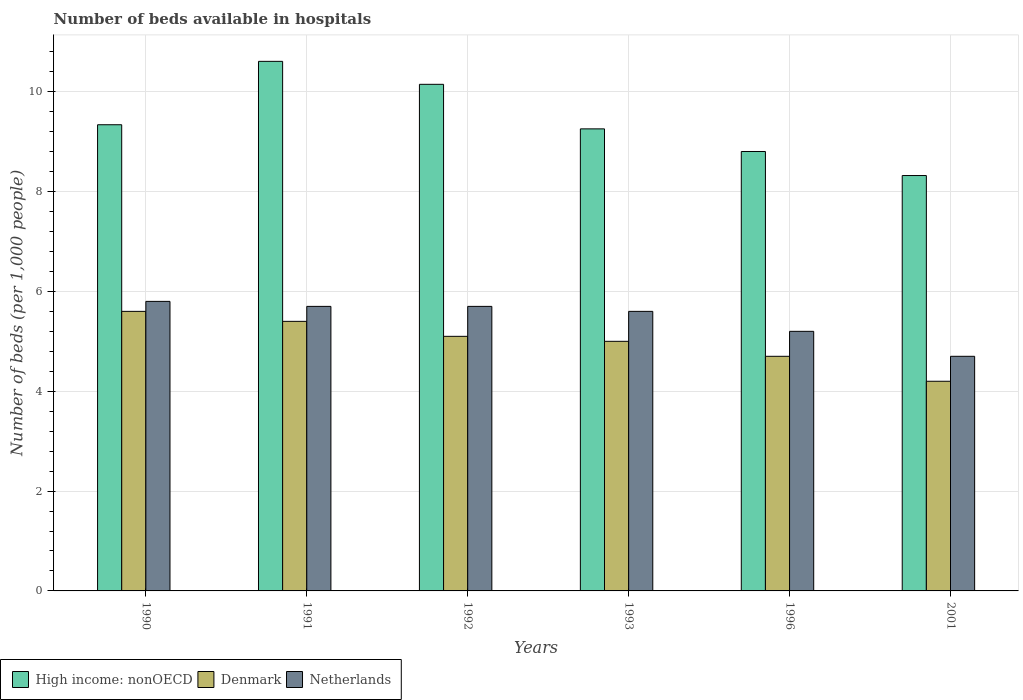How many bars are there on the 6th tick from the right?
Give a very brief answer. 3. What is the label of the 3rd group of bars from the left?
Provide a short and direct response. 1992. In how many cases, is the number of bars for a given year not equal to the number of legend labels?
Give a very brief answer. 0. What is the number of beds in the hospiatls of in High income: nonOECD in 1991?
Ensure brevity in your answer.  10.61. Across all years, what is the maximum number of beds in the hospiatls of in Netherlands?
Offer a terse response. 5.8. Across all years, what is the minimum number of beds in the hospiatls of in High income: nonOECD?
Keep it short and to the point. 8.32. In which year was the number of beds in the hospiatls of in Netherlands maximum?
Your answer should be very brief. 1990. What is the total number of beds in the hospiatls of in Netherlands in the graph?
Offer a very short reply. 32.7. What is the difference between the number of beds in the hospiatls of in Netherlands in 1990 and that in 1992?
Provide a succinct answer. 0.1. What is the difference between the number of beds in the hospiatls of in Netherlands in 1996 and the number of beds in the hospiatls of in Denmark in 1990?
Your answer should be compact. -0.4. What is the average number of beds in the hospiatls of in Netherlands per year?
Your answer should be compact. 5.45. In the year 1990, what is the difference between the number of beds in the hospiatls of in Denmark and number of beds in the hospiatls of in High income: nonOECD?
Make the answer very short. -3.74. What is the ratio of the number of beds in the hospiatls of in High income: nonOECD in 1991 to that in 1993?
Your answer should be very brief. 1.15. Is the number of beds in the hospiatls of in Denmark in 1991 less than that in 1993?
Give a very brief answer. No. Is the difference between the number of beds in the hospiatls of in Denmark in 1991 and 1996 greater than the difference between the number of beds in the hospiatls of in High income: nonOECD in 1991 and 1996?
Your answer should be very brief. No. What is the difference between the highest and the second highest number of beds in the hospiatls of in Netherlands?
Give a very brief answer. 0.1. What is the difference between the highest and the lowest number of beds in the hospiatls of in Netherlands?
Ensure brevity in your answer.  1.1. In how many years, is the number of beds in the hospiatls of in Denmark greater than the average number of beds in the hospiatls of in Denmark taken over all years?
Give a very brief answer. 4. What does the 3rd bar from the left in 1993 represents?
Keep it short and to the point. Netherlands. What does the 3rd bar from the right in 1992 represents?
Provide a short and direct response. High income: nonOECD. Are all the bars in the graph horizontal?
Offer a very short reply. No. How many years are there in the graph?
Offer a very short reply. 6. Are the values on the major ticks of Y-axis written in scientific E-notation?
Offer a very short reply. No. Does the graph contain any zero values?
Your response must be concise. No. Does the graph contain grids?
Your answer should be very brief. Yes. Where does the legend appear in the graph?
Your response must be concise. Bottom left. How are the legend labels stacked?
Make the answer very short. Horizontal. What is the title of the graph?
Your answer should be very brief. Number of beds available in hospitals. What is the label or title of the X-axis?
Your answer should be very brief. Years. What is the label or title of the Y-axis?
Keep it short and to the point. Number of beds (per 1,0 people). What is the Number of beds (per 1,000 people) in High income: nonOECD in 1990?
Provide a short and direct response. 9.34. What is the Number of beds (per 1,000 people) of Denmark in 1990?
Keep it short and to the point. 5.6. What is the Number of beds (per 1,000 people) in Netherlands in 1990?
Ensure brevity in your answer.  5.8. What is the Number of beds (per 1,000 people) in High income: nonOECD in 1991?
Give a very brief answer. 10.61. What is the Number of beds (per 1,000 people) of Denmark in 1991?
Offer a very short reply. 5.4. What is the Number of beds (per 1,000 people) of Netherlands in 1991?
Provide a short and direct response. 5.7. What is the Number of beds (per 1,000 people) in High income: nonOECD in 1992?
Give a very brief answer. 10.15. What is the Number of beds (per 1,000 people) in Denmark in 1992?
Your answer should be compact. 5.1. What is the Number of beds (per 1,000 people) of Netherlands in 1992?
Give a very brief answer. 5.7. What is the Number of beds (per 1,000 people) in High income: nonOECD in 1993?
Keep it short and to the point. 9.26. What is the Number of beds (per 1,000 people) in Denmark in 1993?
Offer a very short reply. 5. What is the Number of beds (per 1,000 people) of Netherlands in 1993?
Keep it short and to the point. 5.6. What is the Number of beds (per 1,000 people) of High income: nonOECD in 1996?
Keep it short and to the point. 8.8. What is the Number of beds (per 1,000 people) of Denmark in 1996?
Your answer should be compact. 4.7. What is the Number of beds (per 1,000 people) of Netherlands in 1996?
Offer a terse response. 5.2. What is the Number of beds (per 1,000 people) of High income: nonOECD in 2001?
Keep it short and to the point. 8.32. What is the Number of beds (per 1,000 people) of Denmark in 2001?
Ensure brevity in your answer.  4.2. What is the Number of beds (per 1,000 people) in Netherlands in 2001?
Make the answer very short. 4.7. Across all years, what is the maximum Number of beds (per 1,000 people) in High income: nonOECD?
Offer a terse response. 10.61. Across all years, what is the maximum Number of beds (per 1,000 people) of Denmark?
Provide a succinct answer. 5.6. Across all years, what is the maximum Number of beds (per 1,000 people) of Netherlands?
Your answer should be compact. 5.8. Across all years, what is the minimum Number of beds (per 1,000 people) of High income: nonOECD?
Your answer should be very brief. 8.32. Across all years, what is the minimum Number of beds (per 1,000 people) of Denmark?
Offer a terse response. 4.2. Across all years, what is the minimum Number of beds (per 1,000 people) in Netherlands?
Ensure brevity in your answer.  4.7. What is the total Number of beds (per 1,000 people) of High income: nonOECD in the graph?
Offer a terse response. 56.47. What is the total Number of beds (per 1,000 people) in Denmark in the graph?
Offer a terse response. 30. What is the total Number of beds (per 1,000 people) of Netherlands in the graph?
Offer a very short reply. 32.7. What is the difference between the Number of beds (per 1,000 people) in High income: nonOECD in 1990 and that in 1991?
Your answer should be compact. -1.27. What is the difference between the Number of beds (per 1,000 people) of Denmark in 1990 and that in 1991?
Offer a terse response. 0.2. What is the difference between the Number of beds (per 1,000 people) of Netherlands in 1990 and that in 1991?
Your answer should be very brief. 0.1. What is the difference between the Number of beds (per 1,000 people) in High income: nonOECD in 1990 and that in 1992?
Your answer should be very brief. -0.81. What is the difference between the Number of beds (per 1,000 people) of Netherlands in 1990 and that in 1992?
Ensure brevity in your answer.  0.1. What is the difference between the Number of beds (per 1,000 people) in High income: nonOECD in 1990 and that in 1993?
Keep it short and to the point. 0.08. What is the difference between the Number of beds (per 1,000 people) of Denmark in 1990 and that in 1993?
Keep it short and to the point. 0.6. What is the difference between the Number of beds (per 1,000 people) of High income: nonOECD in 1990 and that in 1996?
Provide a short and direct response. 0.54. What is the difference between the Number of beds (per 1,000 people) in High income: nonOECD in 1990 and that in 2001?
Your answer should be compact. 1.02. What is the difference between the Number of beds (per 1,000 people) of Denmark in 1990 and that in 2001?
Ensure brevity in your answer.  1.4. What is the difference between the Number of beds (per 1,000 people) of Netherlands in 1990 and that in 2001?
Provide a short and direct response. 1.1. What is the difference between the Number of beds (per 1,000 people) of High income: nonOECD in 1991 and that in 1992?
Your answer should be compact. 0.46. What is the difference between the Number of beds (per 1,000 people) of Denmark in 1991 and that in 1992?
Make the answer very short. 0.3. What is the difference between the Number of beds (per 1,000 people) of High income: nonOECD in 1991 and that in 1993?
Make the answer very short. 1.35. What is the difference between the Number of beds (per 1,000 people) in Denmark in 1991 and that in 1993?
Provide a succinct answer. 0.4. What is the difference between the Number of beds (per 1,000 people) in Netherlands in 1991 and that in 1993?
Your answer should be very brief. 0.1. What is the difference between the Number of beds (per 1,000 people) of High income: nonOECD in 1991 and that in 1996?
Your answer should be compact. 1.81. What is the difference between the Number of beds (per 1,000 people) of Netherlands in 1991 and that in 1996?
Ensure brevity in your answer.  0.5. What is the difference between the Number of beds (per 1,000 people) of High income: nonOECD in 1991 and that in 2001?
Your answer should be very brief. 2.29. What is the difference between the Number of beds (per 1,000 people) in High income: nonOECD in 1992 and that in 1993?
Keep it short and to the point. 0.89. What is the difference between the Number of beds (per 1,000 people) of High income: nonOECD in 1992 and that in 1996?
Provide a succinct answer. 1.35. What is the difference between the Number of beds (per 1,000 people) in Netherlands in 1992 and that in 1996?
Give a very brief answer. 0.5. What is the difference between the Number of beds (per 1,000 people) in High income: nonOECD in 1992 and that in 2001?
Your answer should be compact. 1.83. What is the difference between the Number of beds (per 1,000 people) of High income: nonOECD in 1993 and that in 1996?
Your answer should be very brief. 0.45. What is the difference between the Number of beds (per 1,000 people) of Denmark in 1993 and that in 1996?
Make the answer very short. 0.3. What is the difference between the Number of beds (per 1,000 people) in High income: nonOECD in 1993 and that in 2001?
Your answer should be compact. 0.93. What is the difference between the Number of beds (per 1,000 people) in High income: nonOECD in 1996 and that in 2001?
Provide a succinct answer. 0.48. What is the difference between the Number of beds (per 1,000 people) in High income: nonOECD in 1990 and the Number of beds (per 1,000 people) in Denmark in 1991?
Provide a succinct answer. 3.94. What is the difference between the Number of beds (per 1,000 people) of High income: nonOECD in 1990 and the Number of beds (per 1,000 people) of Netherlands in 1991?
Offer a very short reply. 3.64. What is the difference between the Number of beds (per 1,000 people) in High income: nonOECD in 1990 and the Number of beds (per 1,000 people) in Denmark in 1992?
Provide a short and direct response. 4.24. What is the difference between the Number of beds (per 1,000 people) in High income: nonOECD in 1990 and the Number of beds (per 1,000 people) in Netherlands in 1992?
Provide a succinct answer. 3.64. What is the difference between the Number of beds (per 1,000 people) in High income: nonOECD in 1990 and the Number of beds (per 1,000 people) in Denmark in 1993?
Offer a very short reply. 4.34. What is the difference between the Number of beds (per 1,000 people) of High income: nonOECD in 1990 and the Number of beds (per 1,000 people) of Netherlands in 1993?
Give a very brief answer. 3.74. What is the difference between the Number of beds (per 1,000 people) of Denmark in 1990 and the Number of beds (per 1,000 people) of Netherlands in 1993?
Make the answer very short. 0. What is the difference between the Number of beds (per 1,000 people) of High income: nonOECD in 1990 and the Number of beds (per 1,000 people) of Denmark in 1996?
Your answer should be compact. 4.64. What is the difference between the Number of beds (per 1,000 people) of High income: nonOECD in 1990 and the Number of beds (per 1,000 people) of Netherlands in 1996?
Provide a succinct answer. 4.14. What is the difference between the Number of beds (per 1,000 people) in Denmark in 1990 and the Number of beds (per 1,000 people) in Netherlands in 1996?
Provide a succinct answer. 0.4. What is the difference between the Number of beds (per 1,000 people) of High income: nonOECD in 1990 and the Number of beds (per 1,000 people) of Denmark in 2001?
Your response must be concise. 5.14. What is the difference between the Number of beds (per 1,000 people) in High income: nonOECD in 1990 and the Number of beds (per 1,000 people) in Netherlands in 2001?
Provide a succinct answer. 4.64. What is the difference between the Number of beds (per 1,000 people) of High income: nonOECD in 1991 and the Number of beds (per 1,000 people) of Denmark in 1992?
Offer a terse response. 5.51. What is the difference between the Number of beds (per 1,000 people) in High income: nonOECD in 1991 and the Number of beds (per 1,000 people) in Netherlands in 1992?
Your answer should be compact. 4.91. What is the difference between the Number of beds (per 1,000 people) of High income: nonOECD in 1991 and the Number of beds (per 1,000 people) of Denmark in 1993?
Your answer should be very brief. 5.61. What is the difference between the Number of beds (per 1,000 people) of High income: nonOECD in 1991 and the Number of beds (per 1,000 people) of Netherlands in 1993?
Your response must be concise. 5.01. What is the difference between the Number of beds (per 1,000 people) of Denmark in 1991 and the Number of beds (per 1,000 people) of Netherlands in 1993?
Offer a terse response. -0.2. What is the difference between the Number of beds (per 1,000 people) of High income: nonOECD in 1991 and the Number of beds (per 1,000 people) of Denmark in 1996?
Your answer should be very brief. 5.91. What is the difference between the Number of beds (per 1,000 people) of High income: nonOECD in 1991 and the Number of beds (per 1,000 people) of Netherlands in 1996?
Your response must be concise. 5.41. What is the difference between the Number of beds (per 1,000 people) in High income: nonOECD in 1991 and the Number of beds (per 1,000 people) in Denmark in 2001?
Your response must be concise. 6.41. What is the difference between the Number of beds (per 1,000 people) of High income: nonOECD in 1991 and the Number of beds (per 1,000 people) of Netherlands in 2001?
Ensure brevity in your answer.  5.91. What is the difference between the Number of beds (per 1,000 people) of Denmark in 1991 and the Number of beds (per 1,000 people) of Netherlands in 2001?
Ensure brevity in your answer.  0.7. What is the difference between the Number of beds (per 1,000 people) in High income: nonOECD in 1992 and the Number of beds (per 1,000 people) in Denmark in 1993?
Your answer should be compact. 5.15. What is the difference between the Number of beds (per 1,000 people) in High income: nonOECD in 1992 and the Number of beds (per 1,000 people) in Netherlands in 1993?
Provide a short and direct response. 4.55. What is the difference between the Number of beds (per 1,000 people) of Denmark in 1992 and the Number of beds (per 1,000 people) of Netherlands in 1993?
Ensure brevity in your answer.  -0.5. What is the difference between the Number of beds (per 1,000 people) of High income: nonOECD in 1992 and the Number of beds (per 1,000 people) of Denmark in 1996?
Provide a short and direct response. 5.45. What is the difference between the Number of beds (per 1,000 people) of High income: nonOECD in 1992 and the Number of beds (per 1,000 people) of Netherlands in 1996?
Make the answer very short. 4.95. What is the difference between the Number of beds (per 1,000 people) in High income: nonOECD in 1992 and the Number of beds (per 1,000 people) in Denmark in 2001?
Your response must be concise. 5.95. What is the difference between the Number of beds (per 1,000 people) of High income: nonOECD in 1992 and the Number of beds (per 1,000 people) of Netherlands in 2001?
Keep it short and to the point. 5.45. What is the difference between the Number of beds (per 1,000 people) in Denmark in 1992 and the Number of beds (per 1,000 people) in Netherlands in 2001?
Provide a succinct answer. 0.4. What is the difference between the Number of beds (per 1,000 people) in High income: nonOECD in 1993 and the Number of beds (per 1,000 people) in Denmark in 1996?
Keep it short and to the point. 4.56. What is the difference between the Number of beds (per 1,000 people) in High income: nonOECD in 1993 and the Number of beds (per 1,000 people) in Netherlands in 1996?
Provide a short and direct response. 4.06. What is the difference between the Number of beds (per 1,000 people) of Denmark in 1993 and the Number of beds (per 1,000 people) of Netherlands in 1996?
Keep it short and to the point. -0.2. What is the difference between the Number of beds (per 1,000 people) in High income: nonOECD in 1993 and the Number of beds (per 1,000 people) in Denmark in 2001?
Make the answer very short. 5.06. What is the difference between the Number of beds (per 1,000 people) in High income: nonOECD in 1993 and the Number of beds (per 1,000 people) in Netherlands in 2001?
Your response must be concise. 4.56. What is the difference between the Number of beds (per 1,000 people) in High income: nonOECD in 1996 and the Number of beds (per 1,000 people) in Denmark in 2001?
Offer a terse response. 4.6. What is the difference between the Number of beds (per 1,000 people) in High income: nonOECD in 1996 and the Number of beds (per 1,000 people) in Netherlands in 2001?
Your response must be concise. 4.1. What is the average Number of beds (per 1,000 people) of High income: nonOECD per year?
Your response must be concise. 9.41. What is the average Number of beds (per 1,000 people) of Denmark per year?
Make the answer very short. 5. What is the average Number of beds (per 1,000 people) in Netherlands per year?
Provide a short and direct response. 5.45. In the year 1990, what is the difference between the Number of beds (per 1,000 people) of High income: nonOECD and Number of beds (per 1,000 people) of Denmark?
Your answer should be very brief. 3.74. In the year 1990, what is the difference between the Number of beds (per 1,000 people) in High income: nonOECD and Number of beds (per 1,000 people) in Netherlands?
Your answer should be very brief. 3.54. In the year 1991, what is the difference between the Number of beds (per 1,000 people) of High income: nonOECD and Number of beds (per 1,000 people) of Denmark?
Provide a succinct answer. 5.21. In the year 1991, what is the difference between the Number of beds (per 1,000 people) of High income: nonOECD and Number of beds (per 1,000 people) of Netherlands?
Offer a terse response. 4.91. In the year 1992, what is the difference between the Number of beds (per 1,000 people) of High income: nonOECD and Number of beds (per 1,000 people) of Denmark?
Give a very brief answer. 5.05. In the year 1992, what is the difference between the Number of beds (per 1,000 people) of High income: nonOECD and Number of beds (per 1,000 people) of Netherlands?
Your response must be concise. 4.45. In the year 1993, what is the difference between the Number of beds (per 1,000 people) in High income: nonOECD and Number of beds (per 1,000 people) in Denmark?
Keep it short and to the point. 4.26. In the year 1993, what is the difference between the Number of beds (per 1,000 people) in High income: nonOECD and Number of beds (per 1,000 people) in Netherlands?
Offer a terse response. 3.66. In the year 1993, what is the difference between the Number of beds (per 1,000 people) in Denmark and Number of beds (per 1,000 people) in Netherlands?
Keep it short and to the point. -0.6. In the year 1996, what is the difference between the Number of beds (per 1,000 people) in High income: nonOECD and Number of beds (per 1,000 people) in Denmark?
Offer a terse response. 4.1. In the year 1996, what is the difference between the Number of beds (per 1,000 people) in High income: nonOECD and Number of beds (per 1,000 people) in Netherlands?
Offer a very short reply. 3.6. In the year 1996, what is the difference between the Number of beds (per 1,000 people) in Denmark and Number of beds (per 1,000 people) in Netherlands?
Provide a succinct answer. -0.5. In the year 2001, what is the difference between the Number of beds (per 1,000 people) in High income: nonOECD and Number of beds (per 1,000 people) in Denmark?
Offer a terse response. 4.12. In the year 2001, what is the difference between the Number of beds (per 1,000 people) of High income: nonOECD and Number of beds (per 1,000 people) of Netherlands?
Provide a short and direct response. 3.62. In the year 2001, what is the difference between the Number of beds (per 1,000 people) in Denmark and Number of beds (per 1,000 people) in Netherlands?
Give a very brief answer. -0.5. What is the ratio of the Number of beds (per 1,000 people) in High income: nonOECD in 1990 to that in 1991?
Ensure brevity in your answer.  0.88. What is the ratio of the Number of beds (per 1,000 people) of Denmark in 1990 to that in 1991?
Your answer should be very brief. 1.04. What is the ratio of the Number of beds (per 1,000 people) in Netherlands in 1990 to that in 1991?
Give a very brief answer. 1.02. What is the ratio of the Number of beds (per 1,000 people) in High income: nonOECD in 1990 to that in 1992?
Make the answer very short. 0.92. What is the ratio of the Number of beds (per 1,000 people) of Denmark in 1990 to that in 1992?
Offer a very short reply. 1.1. What is the ratio of the Number of beds (per 1,000 people) in Netherlands in 1990 to that in 1992?
Your response must be concise. 1.02. What is the ratio of the Number of beds (per 1,000 people) of High income: nonOECD in 1990 to that in 1993?
Your response must be concise. 1.01. What is the ratio of the Number of beds (per 1,000 people) of Denmark in 1990 to that in 1993?
Provide a succinct answer. 1.12. What is the ratio of the Number of beds (per 1,000 people) of Netherlands in 1990 to that in 1993?
Give a very brief answer. 1.04. What is the ratio of the Number of beds (per 1,000 people) in High income: nonOECD in 1990 to that in 1996?
Your answer should be very brief. 1.06. What is the ratio of the Number of beds (per 1,000 people) of Denmark in 1990 to that in 1996?
Keep it short and to the point. 1.19. What is the ratio of the Number of beds (per 1,000 people) in Netherlands in 1990 to that in 1996?
Offer a terse response. 1.12. What is the ratio of the Number of beds (per 1,000 people) of High income: nonOECD in 1990 to that in 2001?
Your response must be concise. 1.12. What is the ratio of the Number of beds (per 1,000 people) of Netherlands in 1990 to that in 2001?
Provide a short and direct response. 1.23. What is the ratio of the Number of beds (per 1,000 people) in High income: nonOECD in 1991 to that in 1992?
Offer a very short reply. 1.05. What is the ratio of the Number of beds (per 1,000 people) in Denmark in 1991 to that in 1992?
Give a very brief answer. 1.06. What is the ratio of the Number of beds (per 1,000 people) of High income: nonOECD in 1991 to that in 1993?
Offer a very short reply. 1.15. What is the ratio of the Number of beds (per 1,000 people) of Denmark in 1991 to that in 1993?
Provide a succinct answer. 1.08. What is the ratio of the Number of beds (per 1,000 people) in Netherlands in 1991 to that in 1993?
Ensure brevity in your answer.  1.02. What is the ratio of the Number of beds (per 1,000 people) in High income: nonOECD in 1991 to that in 1996?
Give a very brief answer. 1.21. What is the ratio of the Number of beds (per 1,000 people) in Denmark in 1991 to that in 1996?
Give a very brief answer. 1.15. What is the ratio of the Number of beds (per 1,000 people) in Netherlands in 1991 to that in 1996?
Your response must be concise. 1.1. What is the ratio of the Number of beds (per 1,000 people) of High income: nonOECD in 1991 to that in 2001?
Offer a terse response. 1.27. What is the ratio of the Number of beds (per 1,000 people) of Denmark in 1991 to that in 2001?
Keep it short and to the point. 1.29. What is the ratio of the Number of beds (per 1,000 people) of Netherlands in 1991 to that in 2001?
Your answer should be compact. 1.21. What is the ratio of the Number of beds (per 1,000 people) in High income: nonOECD in 1992 to that in 1993?
Provide a succinct answer. 1.1. What is the ratio of the Number of beds (per 1,000 people) in Denmark in 1992 to that in 1993?
Offer a terse response. 1.02. What is the ratio of the Number of beds (per 1,000 people) in Netherlands in 1992 to that in 1993?
Your answer should be very brief. 1.02. What is the ratio of the Number of beds (per 1,000 people) in High income: nonOECD in 1992 to that in 1996?
Keep it short and to the point. 1.15. What is the ratio of the Number of beds (per 1,000 people) in Denmark in 1992 to that in 1996?
Provide a succinct answer. 1.09. What is the ratio of the Number of beds (per 1,000 people) of Netherlands in 1992 to that in 1996?
Provide a short and direct response. 1.1. What is the ratio of the Number of beds (per 1,000 people) in High income: nonOECD in 1992 to that in 2001?
Your answer should be compact. 1.22. What is the ratio of the Number of beds (per 1,000 people) in Denmark in 1992 to that in 2001?
Make the answer very short. 1.21. What is the ratio of the Number of beds (per 1,000 people) of Netherlands in 1992 to that in 2001?
Offer a very short reply. 1.21. What is the ratio of the Number of beds (per 1,000 people) of High income: nonOECD in 1993 to that in 1996?
Your answer should be very brief. 1.05. What is the ratio of the Number of beds (per 1,000 people) in Denmark in 1993 to that in 1996?
Make the answer very short. 1.06. What is the ratio of the Number of beds (per 1,000 people) of High income: nonOECD in 1993 to that in 2001?
Your answer should be compact. 1.11. What is the ratio of the Number of beds (per 1,000 people) of Denmark in 1993 to that in 2001?
Keep it short and to the point. 1.19. What is the ratio of the Number of beds (per 1,000 people) in Netherlands in 1993 to that in 2001?
Your answer should be very brief. 1.19. What is the ratio of the Number of beds (per 1,000 people) of High income: nonOECD in 1996 to that in 2001?
Make the answer very short. 1.06. What is the ratio of the Number of beds (per 1,000 people) of Denmark in 1996 to that in 2001?
Make the answer very short. 1.12. What is the ratio of the Number of beds (per 1,000 people) in Netherlands in 1996 to that in 2001?
Your answer should be very brief. 1.11. What is the difference between the highest and the second highest Number of beds (per 1,000 people) of High income: nonOECD?
Ensure brevity in your answer.  0.46. What is the difference between the highest and the lowest Number of beds (per 1,000 people) of High income: nonOECD?
Give a very brief answer. 2.29. What is the difference between the highest and the lowest Number of beds (per 1,000 people) of Netherlands?
Provide a succinct answer. 1.1. 